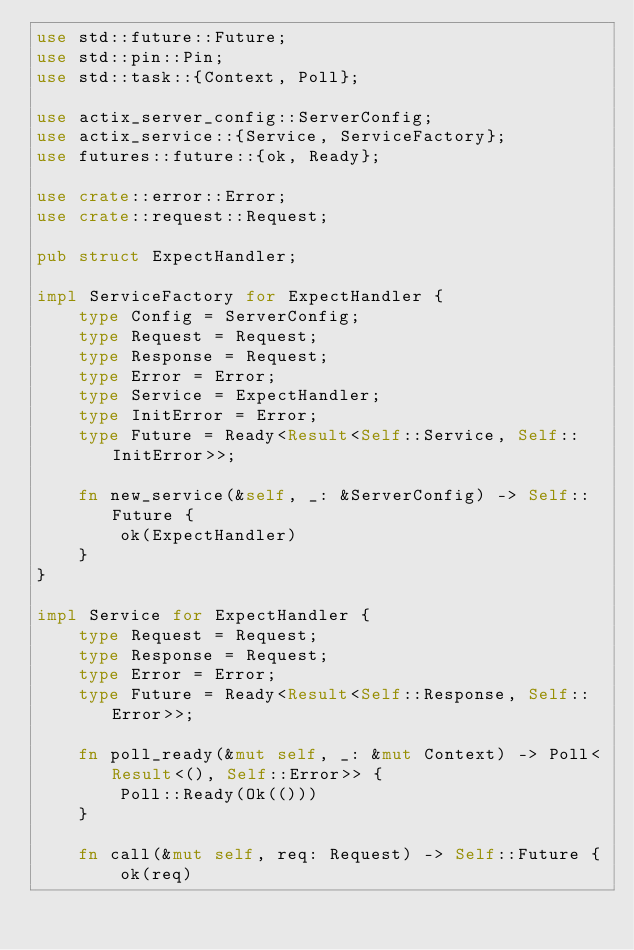Convert code to text. <code><loc_0><loc_0><loc_500><loc_500><_Rust_>use std::future::Future;
use std::pin::Pin;
use std::task::{Context, Poll};

use actix_server_config::ServerConfig;
use actix_service::{Service, ServiceFactory};
use futures::future::{ok, Ready};

use crate::error::Error;
use crate::request::Request;

pub struct ExpectHandler;

impl ServiceFactory for ExpectHandler {
    type Config = ServerConfig;
    type Request = Request;
    type Response = Request;
    type Error = Error;
    type Service = ExpectHandler;
    type InitError = Error;
    type Future = Ready<Result<Self::Service, Self::InitError>>;

    fn new_service(&self, _: &ServerConfig) -> Self::Future {
        ok(ExpectHandler)
    }
}

impl Service for ExpectHandler {
    type Request = Request;
    type Response = Request;
    type Error = Error;
    type Future = Ready<Result<Self::Response, Self::Error>>;

    fn poll_ready(&mut self, _: &mut Context) -> Poll<Result<(), Self::Error>> {
        Poll::Ready(Ok(()))
    }

    fn call(&mut self, req: Request) -> Self::Future {
        ok(req)</code> 